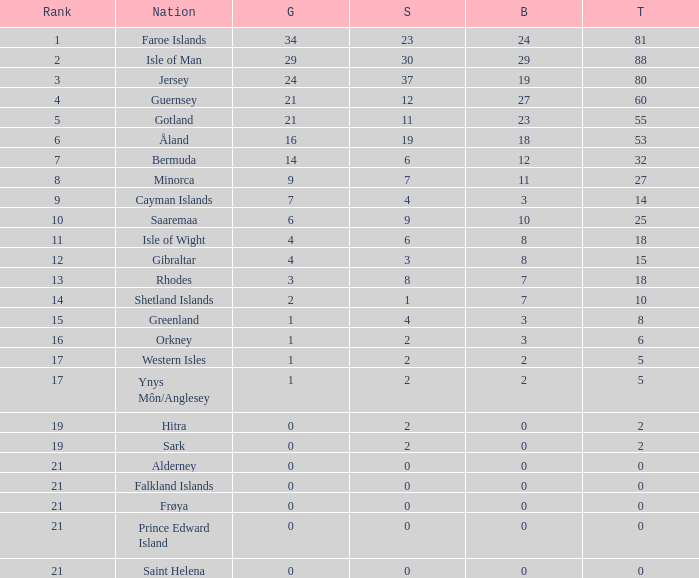How many Silver medals were won in total by all those with more than 3 bronze and exactly 16 gold? 19.0. 